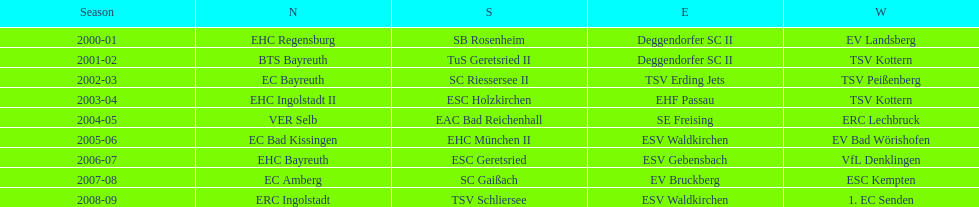What is the number of times deggendorfer sc ii is on the list? 2. 